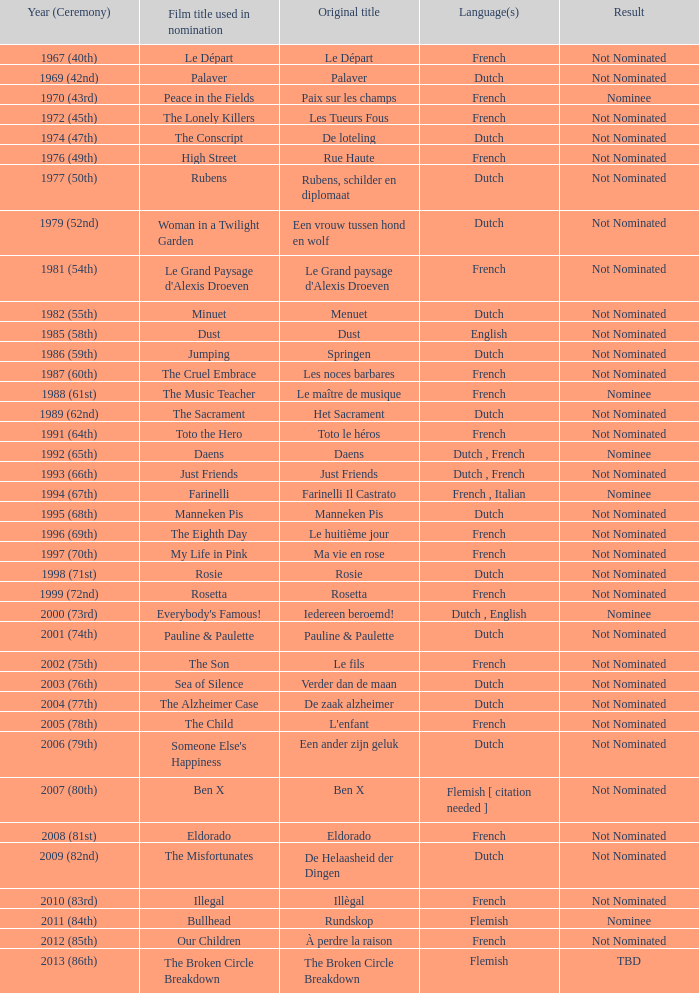What is the language of the film Rosie? Dutch. Can you give me this table as a dict? {'header': ['Year (Ceremony)', 'Film title used in nomination', 'Original title', 'Language(s)', 'Result'], 'rows': [['1967 (40th)', 'Le Départ', 'Le Départ', 'French', 'Not Nominated'], ['1969 (42nd)', 'Palaver', 'Palaver', 'Dutch', 'Not Nominated'], ['1970 (43rd)', 'Peace in the Fields', 'Paix sur les champs', 'French', 'Nominee'], ['1972 (45th)', 'The Lonely Killers', 'Les Tueurs Fous', 'French', 'Not Nominated'], ['1974 (47th)', 'The Conscript', 'De loteling', 'Dutch', 'Not Nominated'], ['1976 (49th)', 'High Street', 'Rue Haute', 'French', 'Not Nominated'], ['1977 (50th)', 'Rubens', 'Rubens, schilder en diplomaat', 'Dutch', 'Not Nominated'], ['1979 (52nd)', 'Woman in a Twilight Garden', 'Een vrouw tussen hond en wolf', 'Dutch', 'Not Nominated'], ['1981 (54th)', "Le Grand Paysage d'Alexis Droeven", "Le Grand paysage d'Alexis Droeven", 'French', 'Not Nominated'], ['1982 (55th)', 'Minuet', 'Menuet', 'Dutch', 'Not Nominated'], ['1985 (58th)', 'Dust', 'Dust', 'English', 'Not Nominated'], ['1986 (59th)', 'Jumping', 'Springen', 'Dutch', 'Not Nominated'], ['1987 (60th)', 'The Cruel Embrace', 'Les noces barbares', 'French', 'Not Nominated'], ['1988 (61st)', 'The Music Teacher', 'Le maître de musique', 'French', 'Nominee'], ['1989 (62nd)', 'The Sacrament', 'Het Sacrament', 'Dutch', 'Not Nominated'], ['1991 (64th)', 'Toto the Hero', 'Toto le héros', 'French', 'Not Nominated'], ['1992 (65th)', 'Daens', 'Daens', 'Dutch , French', 'Nominee'], ['1993 (66th)', 'Just Friends', 'Just Friends', 'Dutch , French', 'Not Nominated'], ['1994 (67th)', 'Farinelli', 'Farinelli Il Castrato', 'French , Italian', 'Nominee'], ['1995 (68th)', 'Manneken Pis', 'Manneken Pis', 'Dutch', 'Not Nominated'], ['1996 (69th)', 'The Eighth Day', 'Le huitième jour', 'French', 'Not Nominated'], ['1997 (70th)', 'My Life in Pink', 'Ma vie en rose', 'French', 'Not Nominated'], ['1998 (71st)', 'Rosie', 'Rosie', 'Dutch', 'Not Nominated'], ['1999 (72nd)', 'Rosetta', 'Rosetta', 'French', 'Not Nominated'], ['2000 (73rd)', "Everybody's Famous!", 'Iedereen beroemd!', 'Dutch , English', 'Nominee'], ['2001 (74th)', 'Pauline & Paulette', 'Pauline & Paulette', 'Dutch', 'Not Nominated'], ['2002 (75th)', 'The Son', 'Le fils', 'French', 'Not Nominated'], ['2003 (76th)', 'Sea of Silence', 'Verder dan de maan', 'Dutch', 'Not Nominated'], ['2004 (77th)', 'The Alzheimer Case', 'De zaak alzheimer', 'Dutch', 'Not Nominated'], ['2005 (78th)', 'The Child', "L'enfant", 'French', 'Not Nominated'], ['2006 (79th)', "Someone Else's Happiness", 'Een ander zijn geluk', 'Dutch', 'Not Nominated'], ['2007 (80th)', 'Ben X', 'Ben X', 'Flemish [ citation needed ]', 'Not Nominated'], ['2008 (81st)', 'Eldorado', 'Eldorado', 'French', 'Not Nominated'], ['2009 (82nd)', 'The Misfortunates', 'De Helaasheid der Dingen', 'Dutch', 'Not Nominated'], ['2010 (83rd)', 'Illegal', 'Illègal', 'French', 'Not Nominated'], ['2011 (84th)', 'Bullhead', 'Rundskop', 'Flemish', 'Nominee'], ['2012 (85th)', 'Our Children', 'À perdre la raison', 'French', 'Not Nominated'], ['2013 (86th)', 'The Broken Circle Breakdown', 'The Broken Circle Breakdown', 'Flemish', 'TBD']]} 